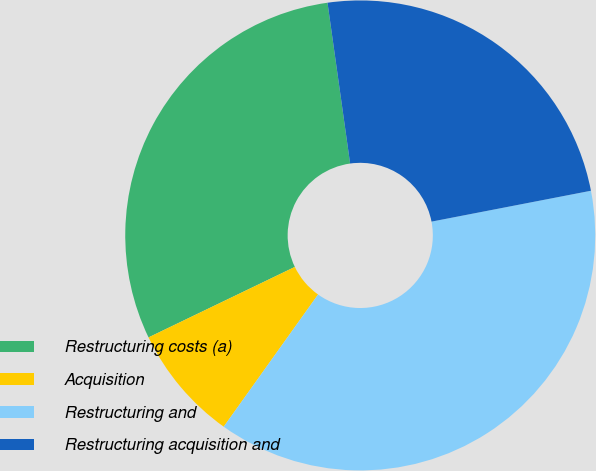<chart> <loc_0><loc_0><loc_500><loc_500><pie_chart><fcel>Restructuring costs (a)<fcel>Acquisition<fcel>Restructuring and<fcel>Restructuring acquisition and<nl><fcel>29.92%<fcel>7.99%<fcel>37.91%<fcel>24.18%<nl></chart> 